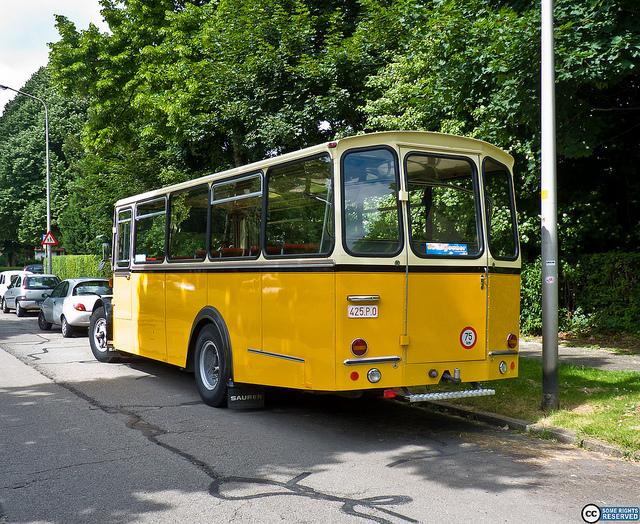What color is the trolley?
Keep it brief. Yellow. How many cars are in front of the trolley?
Keep it brief. 3. How many windows total does the trolley have?
Answer briefly. 14. 